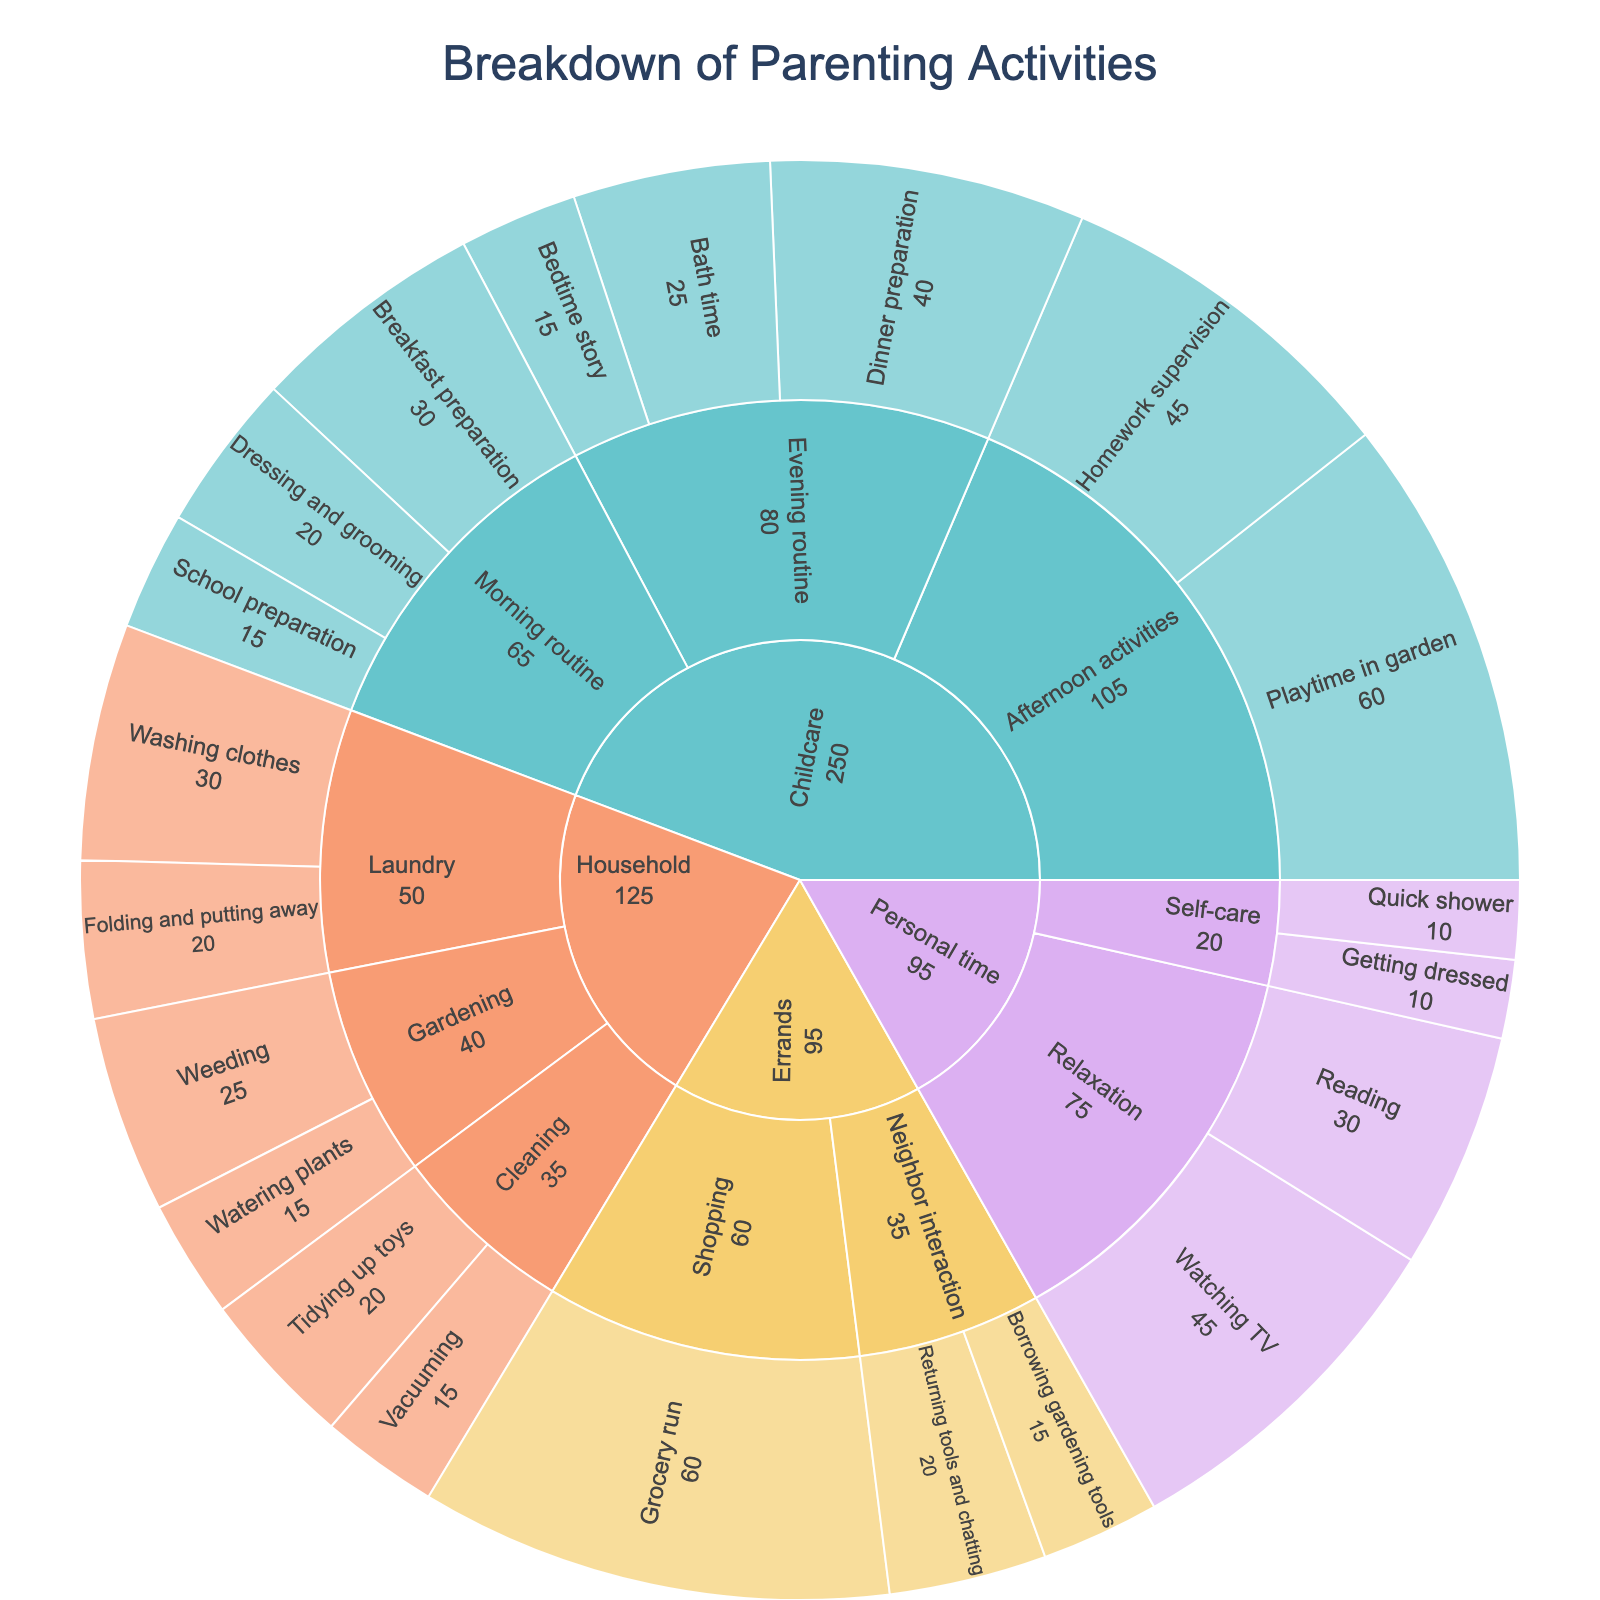What is the title of the figure? The figure title is displayed at the top, centered, highlighting the purpose of the visualization.
Answer: Breakdown of Parenting Activities Which category has the most activities listed? By examining the number of leaves under each main node, we see that "Household" has the most activities listed.
Answer: Household How much total time is spent on Errands? The total time for Errands is calculated by summing the time values for each of its activities. Grocery run (60) + Borrowing gardening tools (15) + Returning tools and chatting (20) = 95 minutes.
Answer: 95 minutes Which activity under Childcare requires the most time? For Childcare, compare the time values for each activity. Playtime in the garden has the highest time value at 60 minutes.
Answer: Playtime in garden How does the time spent on Dinner preparation compare to Playtime in garden? Compare the time values for Dinner preparation (40 minutes) and Playtime in the garden (60 minutes). Dinner preparation takes 20 minutes less than Playtime in the garden.
Answer: 20 minutes less What is the total time spent in the Morning routine under Childcare? Add the time values for activities under Morning routine: Breakfast preparation (30) + Dressing and grooming (20) + School preparation (15) = 65 minutes.
Answer: 65 minutes Which subcategory in Household takes the least total time? Sum the time for each subcategory in Household: Cleaning (Tidying up toys 20 + Vacuuming 15 = 35) Laundry (Washing clothes 30 + Folding and putting away 20 = 50) Gardening (Watering plants 15 + Weeding 25 = 40). Cleaning takes the least total time (35 minutes).
Answer: Cleaning Is more time spent on Self-care or Relaxation within Personal time? Compare the total time: Self-care (Quick shower 10 + Getting dressed 10 = 20) Relaxation (Reading 30 + Watching TV 45 = 75). Relaxation has more time spent (75 minutes).
Answer: Relaxation What proportion of the day is spent on Playtime in garden relative to the total time spent on Childcare activities? Calculate total Childcare time (30+20+15+45+60+40+25+15) = 250 minutes. Playtime in the garden is 60 minutes. Proportion = (60/250) = 24%.
Answer: 24% What is the total time spent on activities involving interaction with the neighbor? Sum the time for activities under this subcategory: Borrowing gardening tools (15) + Returning tools and chatting (20) = 35 minutes.
Answer: 35 minutes 